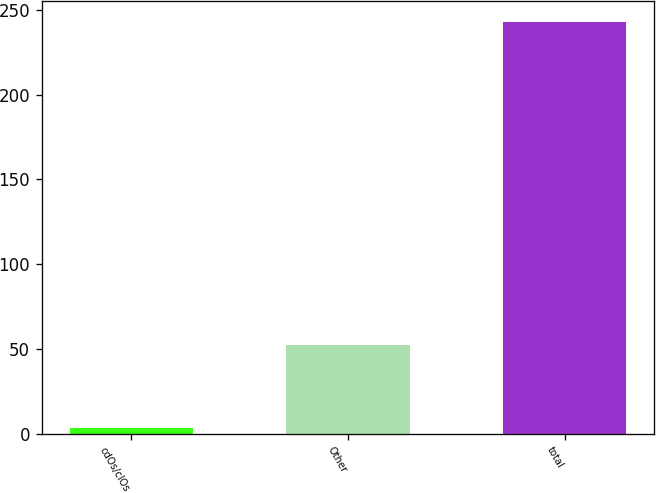Convert chart to OTSL. <chart><loc_0><loc_0><loc_500><loc_500><bar_chart><fcel>cdOs/clOs<fcel>Other<fcel>total<nl><fcel>3<fcel>52<fcel>243<nl></chart> 